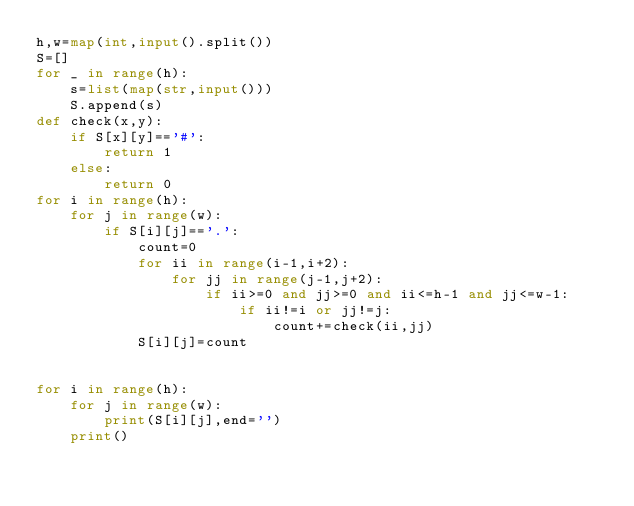<code> <loc_0><loc_0><loc_500><loc_500><_Python_>h,w=map(int,input().split())
S=[]
for _ in range(h):
    s=list(map(str,input()))
    S.append(s)
def check(x,y):
    if S[x][y]=='#':
        return 1
    else:
        return 0
for i in range(h):
    for j in range(w):
        if S[i][j]=='.':
            count=0
            for ii in range(i-1,i+2):
                for jj in range(j-1,j+2):
                    if ii>=0 and jj>=0 and ii<=h-1 and jj<=w-1:
                        if ii!=i or jj!=j:
                            count+=check(ii,jj)
            S[i][j]=count


for i in range(h):
    for j in range(w):
        print(S[i][j],end='')
    print()</code> 